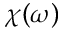<formula> <loc_0><loc_0><loc_500><loc_500>\chi ( \omega )</formula> 